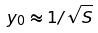<formula> <loc_0><loc_0><loc_500><loc_500>y _ { 0 } \approx 1 / \sqrt { S }</formula> 